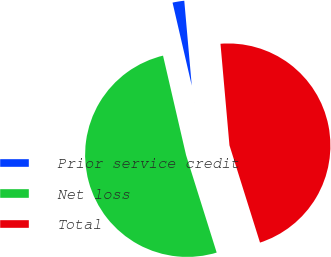Convert chart to OTSL. <chart><loc_0><loc_0><loc_500><loc_500><pie_chart><fcel>Prior service credit<fcel>Net loss<fcel>Total<nl><fcel>2.22%<fcel>51.22%<fcel>46.56%<nl></chart> 